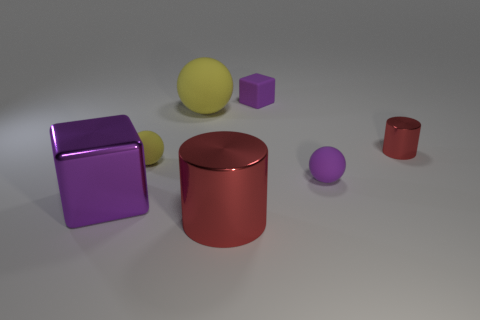There is another object that is the same shape as the big red metal thing; what is it made of?
Give a very brief answer. Metal. Do the big thing behind the small yellow rubber sphere and the big purple block have the same material?
Ensure brevity in your answer.  No. Is the number of large metal objects that are left of the big yellow sphere greater than the number of red shiny cylinders that are behind the small yellow rubber thing?
Offer a very short reply. No. How big is the rubber block?
Your answer should be very brief. Small. There is a big red thing that is made of the same material as the tiny cylinder; what shape is it?
Provide a succinct answer. Cylinder. Do the small matte thing on the left side of the small rubber cube and the large rubber object have the same shape?
Keep it short and to the point. Yes. How many things are either big cyan rubber objects or purple rubber objects?
Ensure brevity in your answer.  2. What is the small object that is to the right of the big yellow object and on the left side of the purple ball made of?
Offer a very short reply. Rubber. Does the purple ball have the same size as the purple rubber block?
Provide a short and direct response. Yes. There is a yellow matte sphere in front of the small red shiny thing behind the big red thing; what size is it?
Keep it short and to the point. Small. 